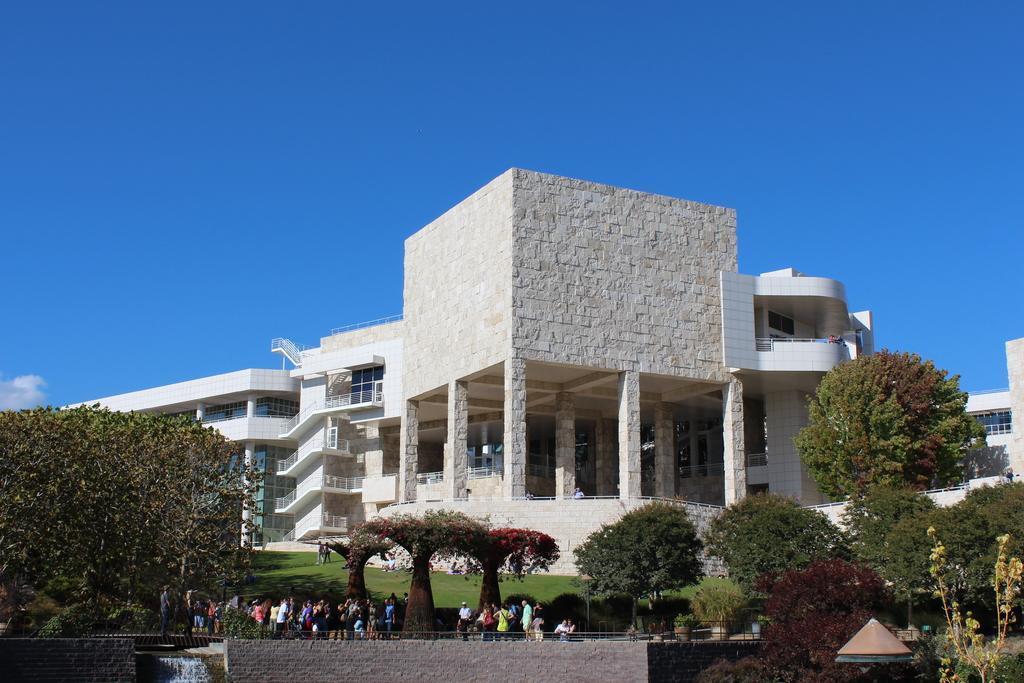Describe this image in one or two sentences. In this picture we can see some trees, there is grass and some people in the middle, in the background there is a building, we can see the sky at the top of the picture, there is a wall at the bottom. 